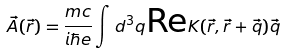Convert formula to latex. <formula><loc_0><loc_0><loc_500><loc_500>\vec { A } ( \vec { r } ) = \frac { m c } { i \hbar { e } } \int d ^ { 3 } q \text {Re} K ( \vec { r } , \vec { r } + \vec { q } ) \vec { q }</formula> 